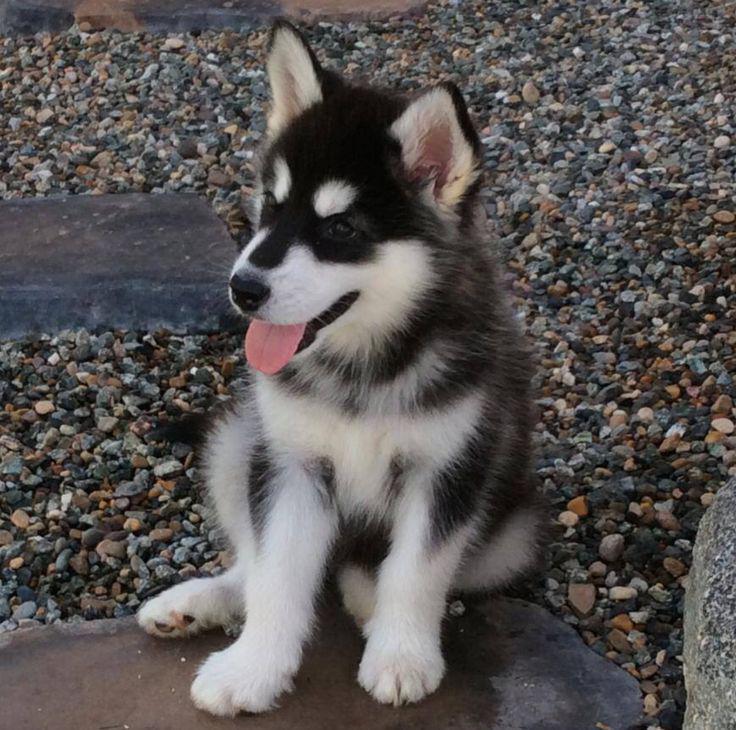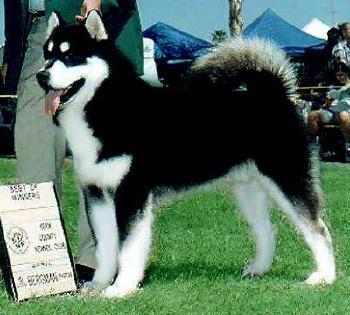The first image is the image on the left, the second image is the image on the right. Given the left and right images, does the statement "a husky is standing in the grass" hold true? Answer yes or no. Yes. The first image is the image on the left, the second image is the image on the right. Given the left and right images, does the statement "The dog in one of the images is standing in the grass." hold true? Answer yes or no. Yes. 